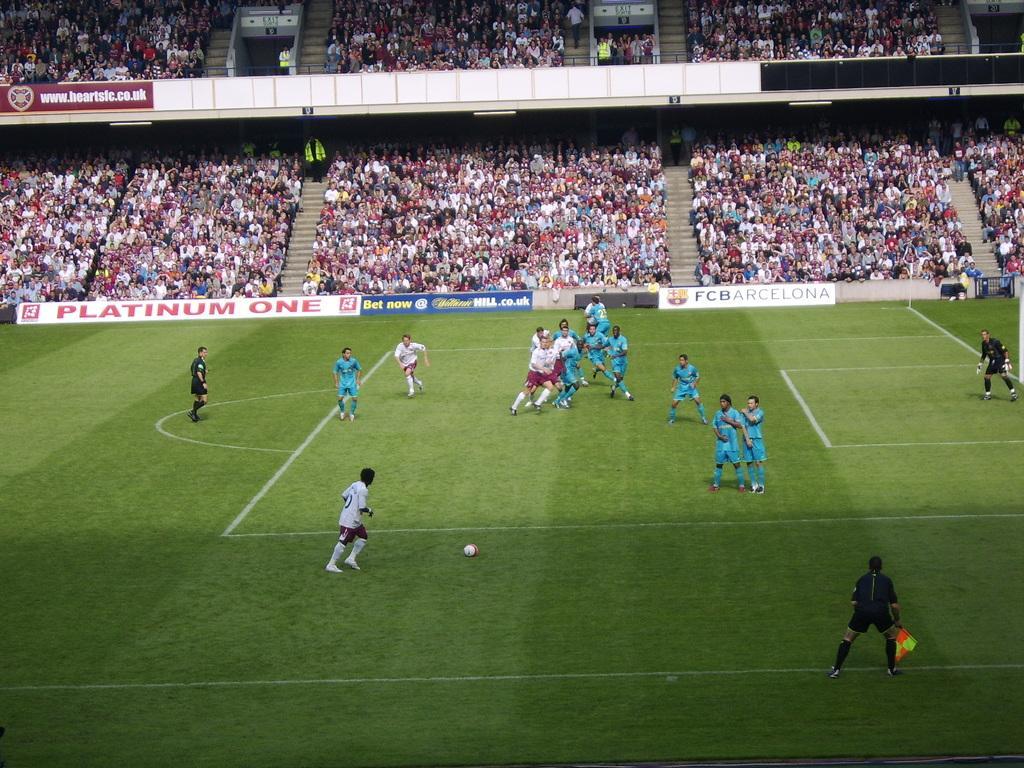Can you describe this image briefly? In this image, we can see a crowd. There are some persons wearing clothes and playing a football. 